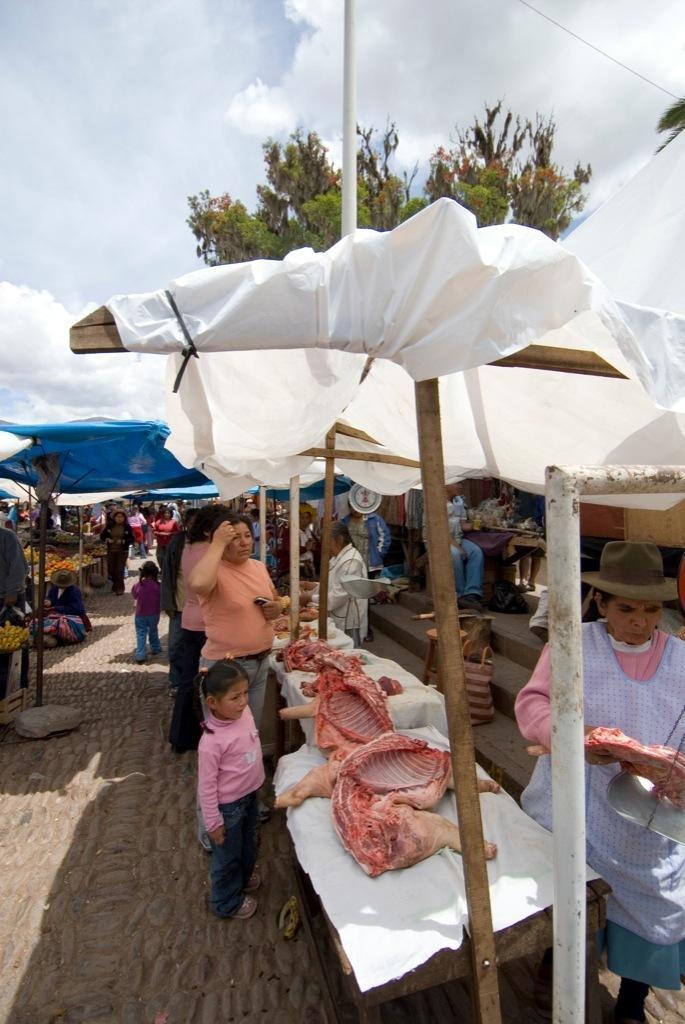How would you summarize this image in a sentence or two? In this picture there are group of people standing under the tent. There is a meat on the table. On the left side of the image there are fruits on the table. At the back there are trees. At the top there is sky and there are clouds. On the right side of the image there is a staircase and there is a person sitting on the chair. 